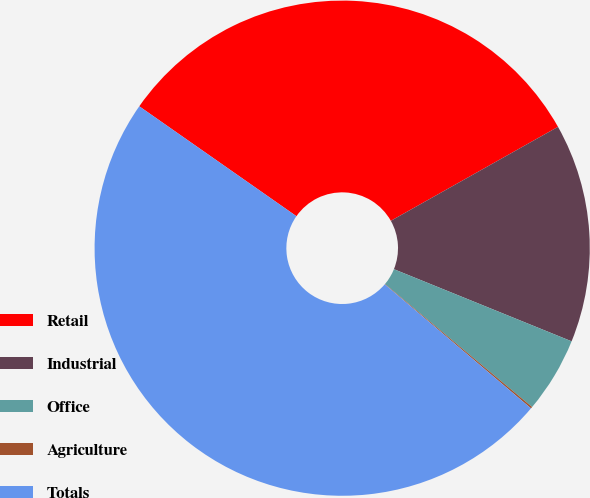Convert chart. <chart><loc_0><loc_0><loc_500><loc_500><pie_chart><fcel>Retail<fcel>Industrial<fcel>Office<fcel>Agriculture<fcel>Totals<nl><fcel>32.14%<fcel>14.29%<fcel>4.95%<fcel>0.11%<fcel>48.52%<nl></chart> 